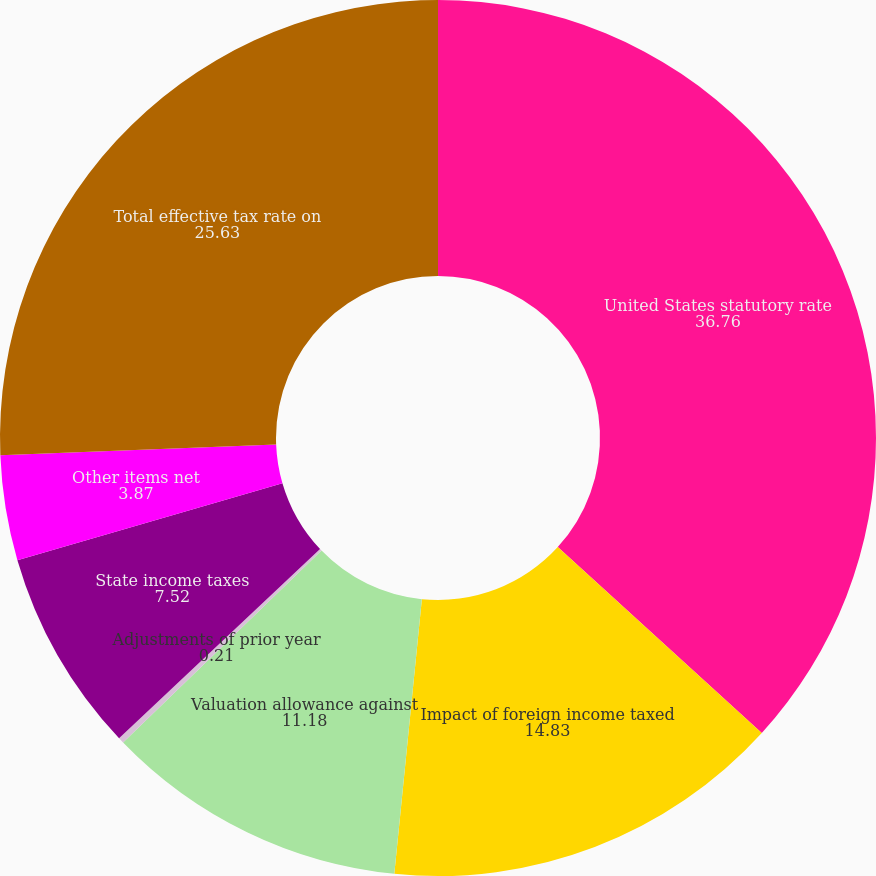<chart> <loc_0><loc_0><loc_500><loc_500><pie_chart><fcel>United States statutory rate<fcel>Impact of foreign income taxed<fcel>Valuation allowance against<fcel>Adjustments of prior year<fcel>State income taxes<fcel>Other items net<fcel>Total effective tax rate on<nl><fcel>36.76%<fcel>14.83%<fcel>11.18%<fcel>0.21%<fcel>7.52%<fcel>3.87%<fcel>25.63%<nl></chart> 